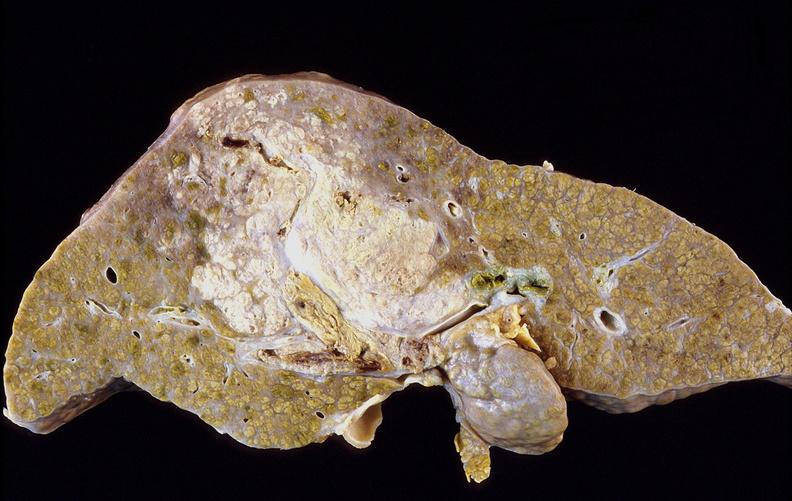what does this image show?
Answer the question using a single word or phrase. Hepatocellular carcinoma 